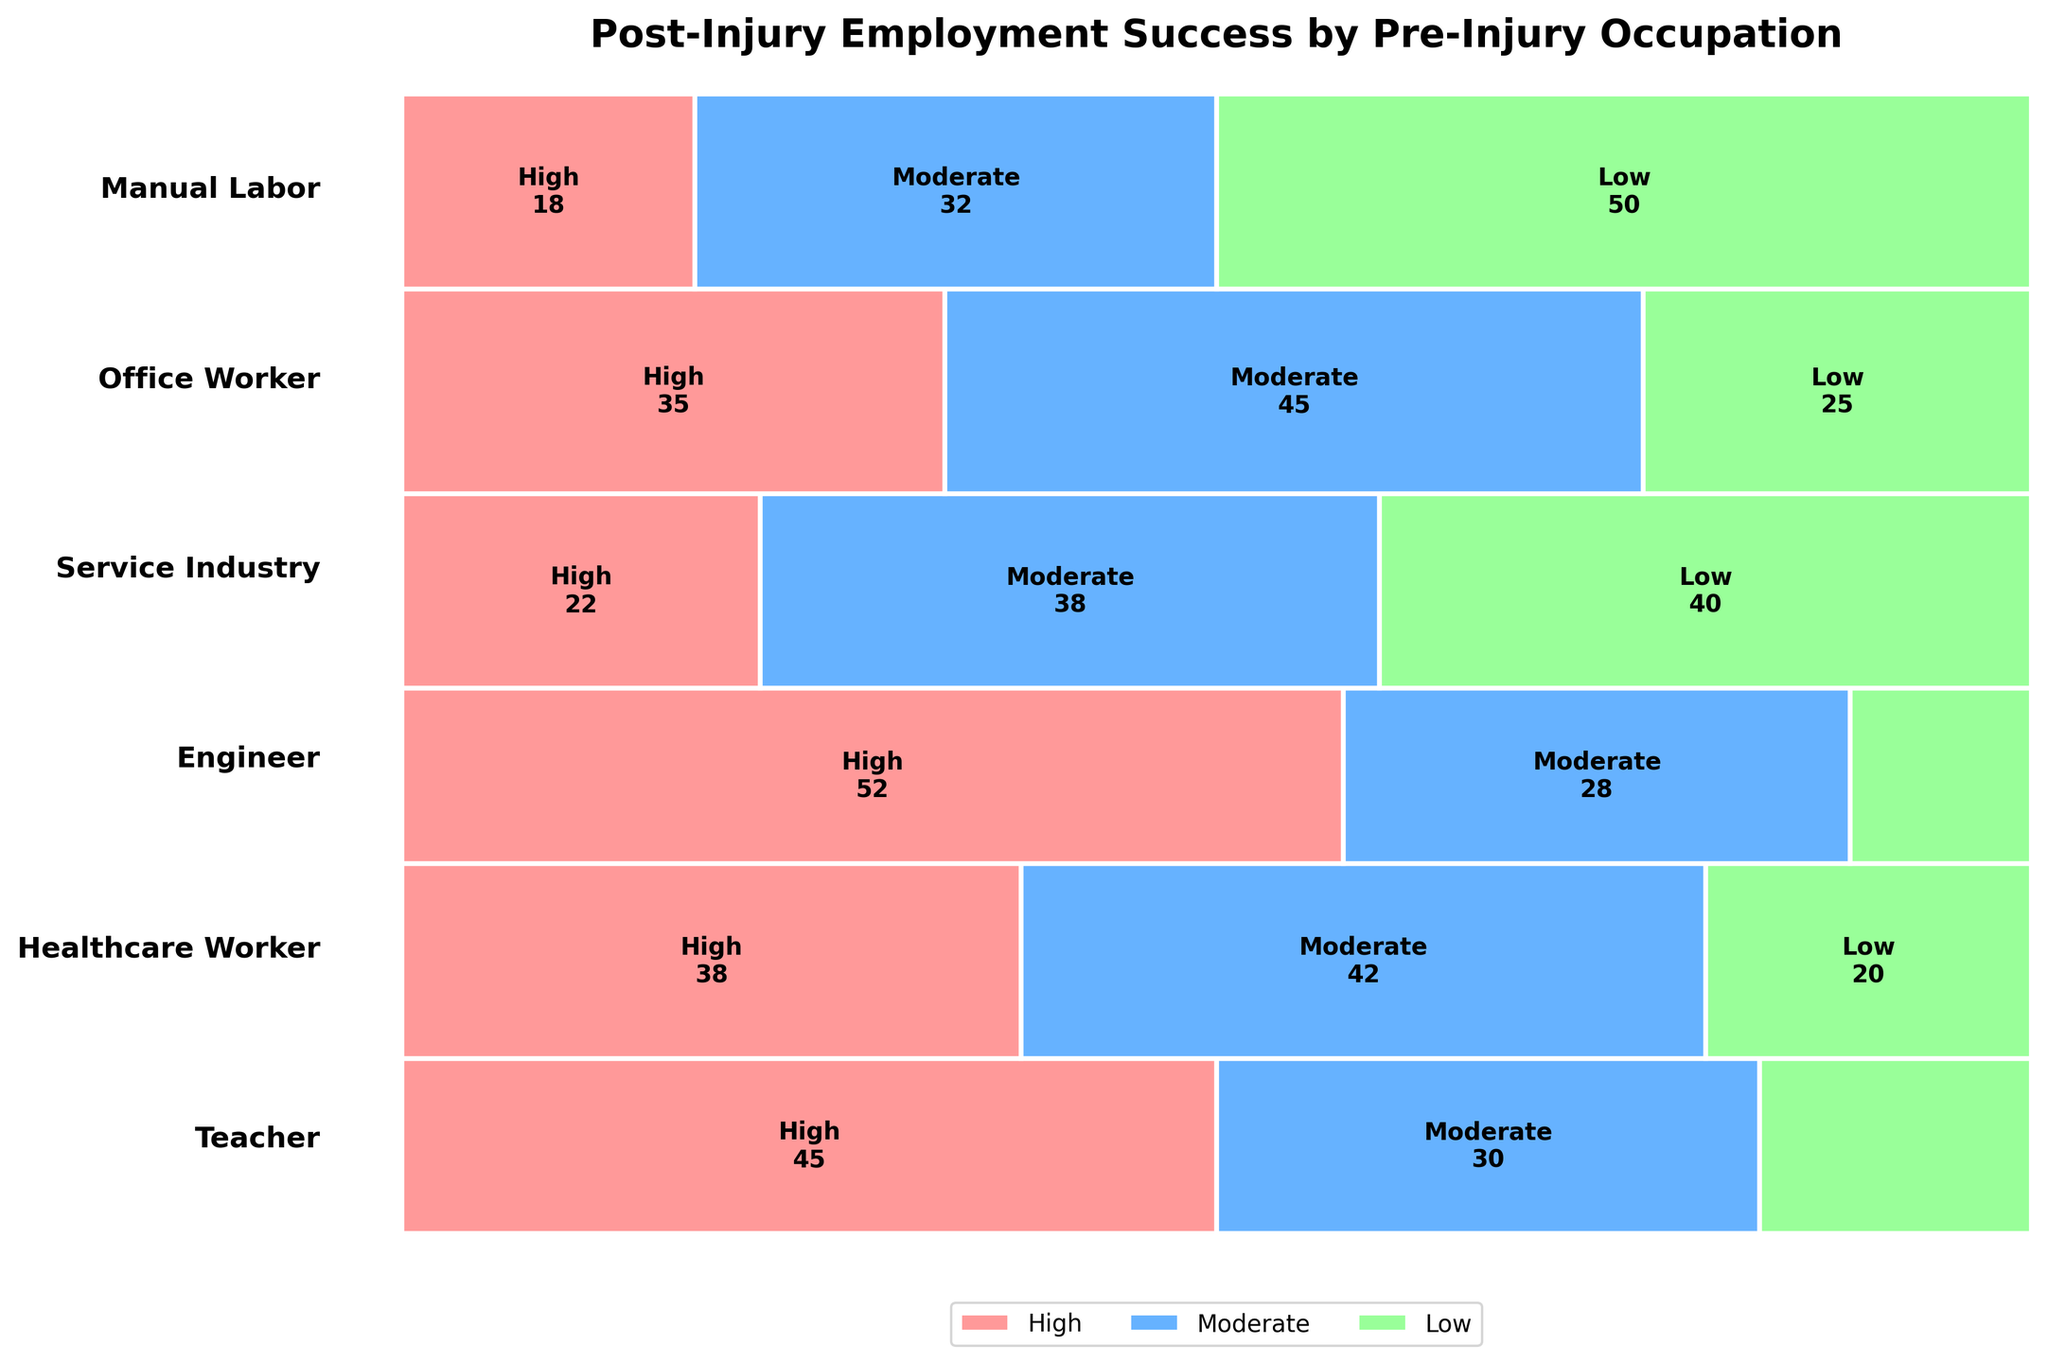What is the title of the plot? The title of the plot is displayed at the top of the figure and provides a summary of what the figure represents.
Answer: Post-Injury Employment Success by Pre-Injury Occupation Which occupation has the highest number of individuals with a high employment success rate? The plot shows different rectangles for each occupation and success rate. The largest rectangle with a high success rate can be visually identified.
Answer: Engineer What is the size relationship between the 'Moderate' and 'Low' employment success categories for Manual Labor workers? Compare the height and width of the rectangles representing the 'Moderate' and 'Low' success rates for Manual Labor workers to understand if one is larger than the other.
Answer: 'Low' is larger How does the employment success of teachers compare to healthcare workers in terms of high success rates? Compare the size of the rectangles representing 'High' success rates for teachers and healthcare workers to see which is larger.
Answer: Teachers have a larger 'High' success rate What proportion of engineers have a moderate employment success rate? Look at the rectangle for engineers with 'Moderate' success and compare its size to the total rectangle for engineers to calculate the proportion.
Answer: 28 out of 90 Which occupation has the smallest 'High' employment success rate rectangle? Visual inspection of the plot shows the smallest rectangle under the 'High' success rate category.
Answer: Manual Labor Are there any occupations with an equal number of individuals in the 'Moderate' and 'High' success categories? By examining the plot, identify if any occupations have rectangles of the same size for 'Moderate' and 'High' success rates.
Answer: No Which occupation has the largest rectangle for low employment success, and what does it represent? Identify the largest rectangle under the 'Low' success rate category and the corresponding occupation.
Answer: Manual Labor, 50 individuals Compare the overall employment success rates between office workers and service industry workers. Look at the three success rate categories for both office workers and service industry workers and compare the sizes of their rectangles.
Answer: Office workers have a more balanced distribution, while service workers have a larger 'Low' success rate How does the proportion of 'Moderate' employment success among healthcare workers compare to that of office workers? Compare the size of the rectangles for 'Moderate' success between healthcare workers and office workers to determine which is larger.
Answer: Office workers have a higher proportion of 'Moderate' success 